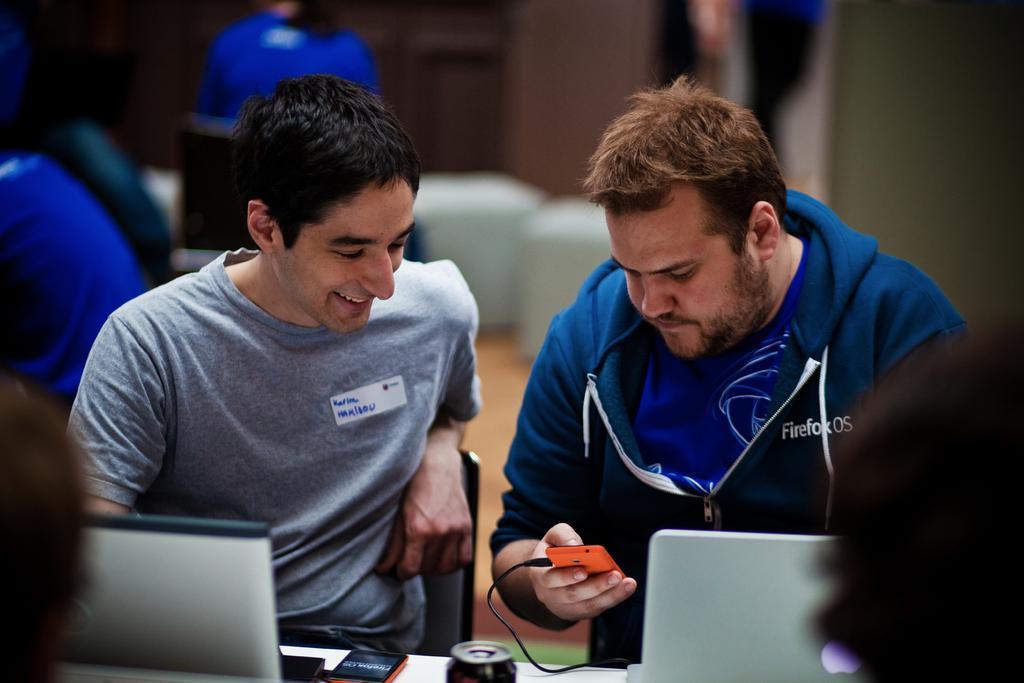Please provide a concise description of this image. In this image I can see there are two men sitting on the chairs, there are laptops, smartphones and there are others in the background. The background of the image is blurred. 